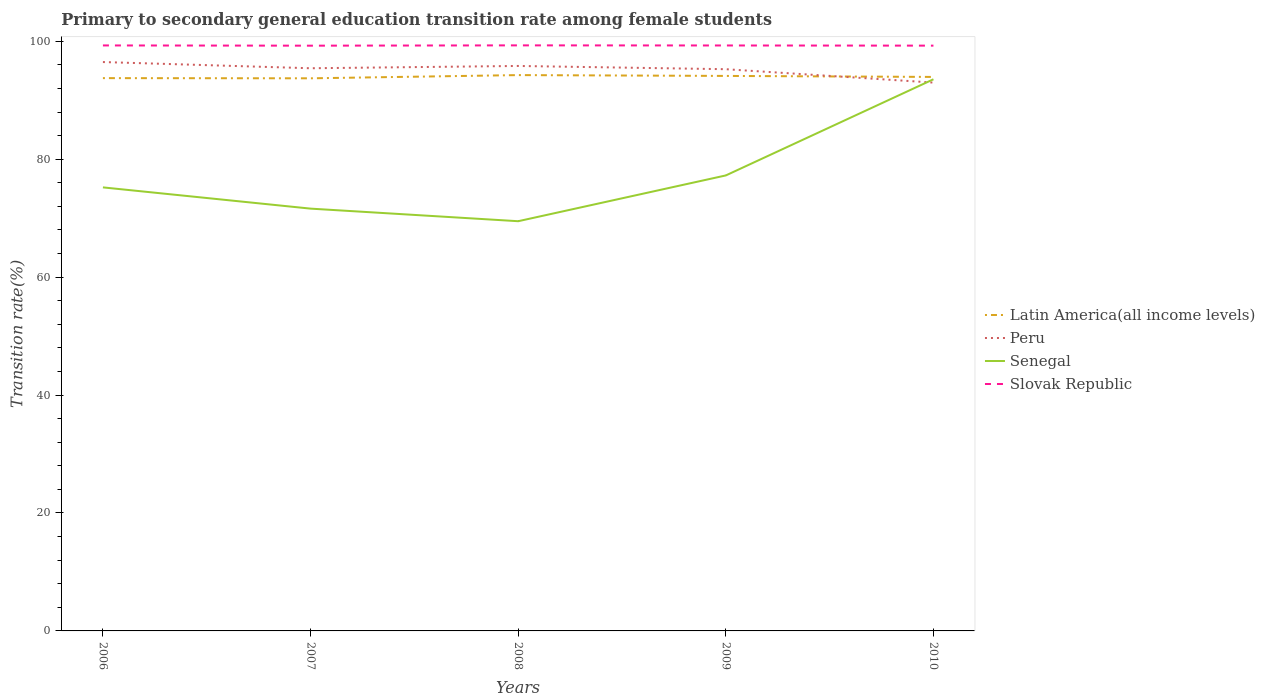Across all years, what is the maximum transition rate in Slovak Republic?
Provide a succinct answer. 99.25. In which year was the transition rate in Peru maximum?
Offer a very short reply. 2010. What is the total transition rate in Slovak Republic in the graph?
Keep it short and to the point. 0.02. What is the difference between the highest and the second highest transition rate in Latin America(all income levels)?
Ensure brevity in your answer.  0.54. What is the difference between the highest and the lowest transition rate in Senegal?
Your answer should be very brief. 1. How many lines are there?
Offer a very short reply. 4. How many years are there in the graph?
Your response must be concise. 5. What is the difference between two consecutive major ticks on the Y-axis?
Make the answer very short. 20. Does the graph contain any zero values?
Provide a succinct answer. No. Does the graph contain grids?
Ensure brevity in your answer.  No. Where does the legend appear in the graph?
Make the answer very short. Center right. How many legend labels are there?
Ensure brevity in your answer.  4. How are the legend labels stacked?
Your answer should be very brief. Vertical. What is the title of the graph?
Make the answer very short. Primary to secondary general education transition rate among female students. Does "Cabo Verde" appear as one of the legend labels in the graph?
Give a very brief answer. No. What is the label or title of the X-axis?
Provide a succinct answer. Years. What is the label or title of the Y-axis?
Offer a terse response. Transition rate(%). What is the Transition rate(%) in Latin America(all income levels) in 2006?
Provide a succinct answer. 93.74. What is the Transition rate(%) in Peru in 2006?
Ensure brevity in your answer.  96.47. What is the Transition rate(%) of Senegal in 2006?
Keep it short and to the point. 75.22. What is the Transition rate(%) in Slovak Republic in 2006?
Offer a terse response. 99.29. What is the Transition rate(%) in Latin America(all income levels) in 2007?
Provide a short and direct response. 93.71. What is the Transition rate(%) in Peru in 2007?
Give a very brief answer. 95.42. What is the Transition rate(%) in Senegal in 2007?
Make the answer very short. 71.61. What is the Transition rate(%) of Slovak Republic in 2007?
Your answer should be compact. 99.25. What is the Transition rate(%) of Latin America(all income levels) in 2008?
Your response must be concise. 94.26. What is the Transition rate(%) of Peru in 2008?
Keep it short and to the point. 95.81. What is the Transition rate(%) in Senegal in 2008?
Give a very brief answer. 69.48. What is the Transition rate(%) in Slovak Republic in 2008?
Make the answer very short. 99.3. What is the Transition rate(%) of Latin America(all income levels) in 2009?
Keep it short and to the point. 94.12. What is the Transition rate(%) of Peru in 2009?
Give a very brief answer. 95.26. What is the Transition rate(%) in Senegal in 2009?
Provide a short and direct response. 77.24. What is the Transition rate(%) of Slovak Republic in 2009?
Make the answer very short. 99.28. What is the Transition rate(%) in Latin America(all income levels) in 2010?
Make the answer very short. 93.95. What is the Transition rate(%) of Peru in 2010?
Offer a terse response. 92.99. What is the Transition rate(%) in Senegal in 2010?
Your answer should be compact. 93.55. What is the Transition rate(%) in Slovak Republic in 2010?
Offer a terse response. 99.25. Across all years, what is the maximum Transition rate(%) in Latin America(all income levels)?
Ensure brevity in your answer.  94.26. Across all years, what is the maximum Transition rate(%) in Peru?
Offer a very short reply. 96.47. Across all years, what is the maximum Transition rate(%) in Senegal?
Your response must be concise. 93.55. Across all years, what is the maximum Transition rate(%) in Slovak Republic?
Offer a very short reply. 99.3. Across all years, what is the minimum Transition rate(%) of Latin America(all income levels)?
Your response must be concise. 93.71. Across all years, what is the minimum Transition rate(%) of Peru?
Make the answer very short. 92.99. Across all years, what is the minimum Transition rate(%) of Senegal?
Give a very brief answer. 69.48. Across all years, what is the minimum Transition rate(%) in Slovak Republic?
Give a very brief answer. 99.25. What is the total Transition rate(%) of Latin America(all income levels) in the graph?
Your response must be concise. 469.78. What is the total Transition rate(%) of Peru in the graph?
Give a very brief answer. 475.95. What is the total Transition rate(%) of Senegal in the graph?
Make the answer very short. 387.1. What is the total Transition rate(%) in Slovak Republic in the graph?
Give a very brief answer. 496.37. What is the difference between the Transition rate(%) in Latin America(all income levels) in 2006 and that in 2007?
Make the answer very short. 0.03. What is the difference between the Transition rate(%) of Peru in 2006 and that in 2007?
Offer a terse response. 1.05. What is the difference between the Transition rate(%) of Senegal in 2006 and that in 2007?
Give a very brief answer. 3.6. What is the difference between the Transition rate(%) of Slovak Republic in 2006 and that in 2007?
Provide a succinct answer. 0.04. What is the difference between the Transition rate(%) in Latin America(all income levels) in 2006 and that in 2008?
Offer a very short reply. -0.51. What is the difference between the Transition rate(%) in Peru in 2006 and that in 2008?
Offer a very short reply. 0.66. What is the difference between the Transition rate(%) of Senegal in 2006 and that in 2008?
Offer a terse response. 5.74. What is the difference between the Transition rate(%) of Slovak Republic in 2006 and that in 2008?
Give a very brief answer. -0.01. What is the difference between the Transition rate(%) in Latin America(all income levels) in 2006 and that in 2009?
Offer a terse response. -0.37. What is the difference between the Transition rate(%) in Peru in 2006 and that in 2009?
Provide a succinct answer. 1.21. What is the difference between the Transition rate(%) of Senegal in 2006 and that in 2009?
Offer a very short reply. -2.03. What is the difference between the Transition rate(%) in Slovak Republic in 2006 and that in 2009?
Ensure brevity in your answer.  0.01. What is the difference between the Transition rate(%) in Latin America(all income levels) in 2006 and that in 2010?
Give a very brief answer. -0.2. What is the difference between the Transition rate(%) of Peru in 2006 and that in 2010?
Provide a succinct answer. 3.48. What is the difference between the Transition rate(%) of Senegal in 2006 and that in 2010?
Offer a very short reply. -18.33. What is the difference between the Transition rate(%) in Slovak Republic in 2006 and that in 2010?
Provide a short and direct response. 0.03. What is the difference between the Transition rate(%) of Latin America(all income levels) in 2007 and that in 2008?
Your answer should be compact. -0.54. What is the difference between the Transition rate(%) of Peru in 2007 and that in 2008?
Make the answer very short. -0.39. What is the difference between the Transition rate(%) of Senegal in 2007 and that in 2008?
Provide a short and direct response. 2.13. What is the difference between the Transition rate(%) in Slovak Republic in 2007 and that in 2008?
Ensure brevity in your answer.  -0.05. What is the difference between the Transition rate(%) of Latin America(all income levels) in 2007 and that in 2009?
Your answer should be very brief. -0.41. What is the difference between the Transition rate(%) of Peru in 2007 and that in 2009?
Offer a very short reply. 0.16. What is the difference between the Transition rate(%) of Senegal in 2007 and that in 2009?
Give a very brief answer. -5.63. What is the difference between the Transition rate(%) of Slovak Republic in 2007 and that in 2009?
Offer a terse response. -0.03. What is the difference between the Transition rate(%) of Latin America(all income levels) in 2007 and that in 2010?
Give a very brief answer. -0.23. What is the difference between the Transition rate(%) in Peru in 2007 and that in 2010?
Your response must be concise. 2.43. What is the difference between the Transition rate(%) in Senegal in 2007 and that in 2010?
Offer a terse response. -21.94. What is the difference between the Transition rate(%) in Slovak Republic in 2007 and that in 2010?
Offer a terse response. -0.01. What is the difference between the Transition rate(%) of Latin America(all income levels) in 2008 and that in 2009?
Your answer should be compact. 0.14. What is the difference between the Transition rate(%) in Peru in 2008 and that in 2009?
Provide a short and direct response. 0.55. What is the difference between the Transition rate(%) in Senegal in 2008 and that in 2009?
Provide a short and direct response. -7.76. What is the difference between the Transition rate(%) in Slovak Republic in 2008 and that in 2009?
Your answer should be very brief. 0.02. What is the difference between the Transition rate(%) of Latin America(all income levels) in 2008 and that in 2010?
Your answer should be compact. 0.31. What is the difference between the Transition rate(%) in Peru in 2008 and that in 2010?
Your answer should be compact. 2.82. What is the difference between the Transition rate(%) of Senegal in 2008 and that in 2010?
Give a very brief answer. -24.07. What is the difference between the Transition rate(%) of Slovak Republic in 2008 and that in 2010?
Make the answer very short. 0.05. What is the difference between the Transition rate(%) of Latin America(all income levels) in 2009 and that in 2010?
Provide a succinct answer. 0.17. What is the difference between the Transition rate(%) of Peru in 2009 and that in 2010?
Your response must be concise. 2.27. What is the difference between the Transition rate(%) in Senegal in 2009 and that in 2010?
Provide a succinct answer. -16.31. What is the difference between the Transition rate(%) of Slovak Republic in 2009 and that in 2010?
Keep it short and to the point. 0.03. What is the difference between the Transition rate(%) in Latin America(all income levels) in 2006 and the Transition rate(%) in Peru in 2007?
Offer a terse response. -1.67. What is the difference between the Transition rate(%) in Latin America(all income levels) in 2006 and the Transition rate(%) in Senegal in 2007?
Provide a succinct answer. 22.13. What is the difference between the Transition rate(%) in Latin America(all income levels) in 2006 and the Transition rate(%) in Slovak Republic in 2007?
Ensure brevity in your answer.  -5.5. What is the difference between the Transition rate(%) in Peru in 2006 and the Transition rate(%) in Senegal in 2007?
Provide a succinct answer. 24.86. What is the difference between the Transition rate(%) in Peru in 2006 and the Transition rate(%) in Slovak Republic in 2007?
Make the answer very short. -2.78. What is the difference between the Transition rate(%) of Senegal in 2006 and the Transition rate(%) of Slovak Republic in 2007?
Your answer should be very brief. -24.03. What is the difference between the Transition rate(%) of Latin America(all income levels) in 2006 and the Transition rate(%) of Peru in 2008?
Provide a short and direct response. -2.06. What is the difference between the Transition rate(%) of Latin America(all income levels) in 2006 and the Transition rate(%) of Senegal in 2008?
Offer a terse response. 24.26. What is the difference between the Transition rate(%) in Latin America(all income levels) in 2006 and the Transition rate(%) in Slovak Republic in 2008?
Provide a succinct answer. -5.56. What is the difference between the Transition rate(%) of Peru in 2006 and the Transition rate(%) of Senegal in 2008?
Offer a very short reply. 26.99. What is the difference between the Transition rate(%) of Peru in 2006 and the Transition rate(%) of Slovak Republic in 2008?
Your answer should be compact. -2.83. What is the difference between the Transition rate(%) in Senegal in 2006 and the Transition rate(%) in Slovak Republic in 2008?
Keep it short and to the point. -24.08. What is the difference between the Transition rate(%) of Latin America(all income levels) in 2006 and the Transition rate(%) of Peru in 2009?
Your answer should be compact. -1.51. What is the difference between the Transition rate(%) of Latin America(all income levels) in 2006 and the Transition rate(%) of Senegal in 2009?
Provide a short and direct response. 16.5. What is the difference between the Transition rate(%) of Latin America(all income levels) in 2006 and the Transition rate(%) of Slovak Republic in 2009?
Your answer should be compact. -5.54. What is the difference between the Transition rate(%) in Peru in 2006 and the Transition rate(%) in Senegal in 2009?
Your answer should be very brief. 19.23. What is the difference between the Transition rate(%) of Peru in 2006 and the Transition rate(%) of Slovak Republic in 2009?
Provide a short and direct response. -2.81. What is the difference between the Transition rate(%) in Senegal in 2006 and the Transition rate(%) in Slovak Republic in 2009?
Give a very brief answer. -24.06. What is the difference between the Transition rate(%) of Latin America(all income levels) in 2006 and the Transition rate(%) of Peru in 2010?
Offer a terse response. 0.76. What is the difference between the Transition rate(%) in Latin America(all income levels) in 2006 and the Transition rate(%) in Senegal in 2010?
Make the answer very short. 0.2. What is the difference between the Transition rate(%) in Latin America(all income levels) in 2006 and the Transition rate(%) in Slovak Republic in 2010?
Offer a very short reply. -5.51. What is the difference between the Transition rate(%) in Peru in 2006 and the Transition rate(%) in Senegal in 2010?
Provide a short and direct response. 2.92. What is the difference between the Transition rate(%) of Peru in 2006 and the Transition rate(%) of Slovak Republic in 2010?
Ensure brevity in your answer.  -2.78. What is the difference between the Transition rate(%) of Senegal in 2006 and the Transition rate(%) of Slovak Republic in 2010?
Keep it short and to the point. -24.04. What is the difference between the Transition rate(%) of Latin America(all income levels) in 2007 and the Transition rate(%) of Peru in 2008?
Offer a terse response. -2.09. What is the difference between the Transition rate(%) in Latin America(all income levels) in 2007 and the Transition rate(%) in Senegal in 2008?
Provide a short and direct response. 24.23. What is the difference between the Transition rate(%) of Latin America(all income levels) in 2007 and the Transition rate(%) of Slovak Republic in 2008?
Your answer should be compact. -5.59. What is the difference between the Transition rate(%) of Peru in 2007 and the Transition rate(%) of Senegal in 2008?
Give a very brief answer. 25.94. What is the difference between the Transition rate(%) of Peru in 2007 and the Transition rate(%) of Slovak Republic in 2008?
Make the answer very short. -3.88. What is the difference between the Transition rate(%) of Senegal in 2007 and the Transition rate(%) of Slovak Republic in 2008?
Offer a terse response. -27.69. What is the difference between the Transition rate(%) in Latin America(all income levels) in 2007 and the Transition rate(%) in Peru in 2009?
Your response must be concise. -1.55. What is the difference between the Transition rate(%) of Latin America(all income levels) in 2007 and the Transition rate(%) of Senegal in 2009?
Provide a succinct answer. 16.47. What is the difference between the Transition rate(%) of Latin America(all income levels) in 2007 and the Transition rate(%) of Slovak Republic in 2009?
Keep it short and to the point. -5.57. What is the difference between the Transition rate(%) in Peru in 2007 and the Transition rate(%) in Senegal in 2009?
Provide a succinct answer. 18.18. What is the difference between the Transition rate(%) in Peru in 2007 and the Transition rate(%) in Slovak Republic in 2009?
Give a very brief answer. -3.86. What is the difference between the Transition rate(%) in Senegal in 2007 and the Transition rate(%) in Slovak Republic in 2009?
Your answer should be very brief. -27.67. What is the difference between the Transition rate(%) of Latin America(all income levels) in 2007 and the Transition rate(%) of Peru in 2010?
Your answer should be very brief. 0.73. What is the difference between the Transition rate(%) of Latin America(all income levels) in 2007 and the Transition rate(%) of Senegal in 2010?
Your response must be concise. 0.16. What is the difference between the Transition rate(%) in Latin America(all income levels) in 2007 and the Transition rate(%) in Slovak Republic in 2010?
Your answer should be very brief. -5.54. What is the difference between the Transition rate(%) of Peru in 2007 and the Transition rate(%) of Senegal in 2010?
Offer a terse response. 1.87. What is the difference between the Transition rate(%) of Peru in 2007 and the Transition rate(%) of Slovak Republic in 2010?
Provide a succinct answer. -3.83. What is the difference between the Transition rate(%) in Senegal in 2007 and the Transition rate(%) in Slovak Republic in 2010?
Make the answer very short. -27.64. What is the difference between the Transition rate(%) in Latin America(all income levels) in 2008 and the Transition rate(%) in Peru in 2009?
Your answer should be very brief. -1. What is the difference between the Transition rate(%) in Latin America(all income levels) in 2008 and the Transition rate(%) in Senegal in 2009?
Offer a very short reply. 17.01. What is the difference between the Transition rate(%) in Latin America(all income levels) in 2008 and the Transition rate(%) in Slovak Republic in 2009?
Offer a very short reply. -5.02. What is the difference between the Transition rate(%) in Peru in 2008 and the Transition rate(%) in Senegal in 2009?
Offer a very short reply. 18.56. What is the difference between the Transition rate(%) of Peru in 2008 and the Transition rate(%) of Slovak Republic in 2009?
Ensure brevity in your answer.  -3.47. What is the difference between the Transition rate(%) of Senegal in 2008 and the Transition rate(%) of Slovak Republic in 2009?
Make the answer very short. -29.8. What is the difference between the Transition rate(%) in Latin America(all income levels) in 2008 and the Transition rate(%) in Peru in 2010?
Make the answer very short. 1.27. What is the difference between the Transition rate(%) of Latin America(all income levels) in 2008 and the Transition rate(%) of Senegal in 2010?
Ensure brevity in your answer.  0.71. What is the difference between the Transition rate(%) of Latin America(all income levels) in 2008 and the Transition rate(%) of Slovak Republic in 2010?
Provide a succinct answer. -5. What is the difference between the Transition rate(%) in Peru in 2008 and the Transition rate(%) in Senegal in 2010?
Your answer should be very brief. 2.26. What is the difference between the Transition rate(%) of Peru in 2008 and the Transition rate(%) of Slovak Republic in 2010?
Offer a very short reply. -3.45. What is the difference between the Transition rate(%) of Senegal in 2008 and the Transition rate(%) of Slovak Republic in 2010?
Give a very brief answer. -29.77. What is the difference between the Transition rate(%) in Latin America(all income levels) in 2009 and the Transition rate(%) in Peru in 2010?
Offer a terse response. 1.13. What is the difference between the Transition rate(%) of Latin America(all income levels) in 2009 and the Transition rate(%) of Senegal in 2010?
Keep it short and to the point. 0.57. What is the difference between the Transition rate(%) in Latin America(all income levels) in 2009 and the Transition rate(%) in Slovak Republic in 2010?
Provide a short and direct response. -5.14. What is the difference between the Transition rate(%) of Peru in 2009 and the Transition rate(%) of Senegal in 2010?
Make the answer very short. 1.71. What is the difference between the Transition rate(%) in Peru in 2009 and the Transition rate(%) in Slovak Republic in 2010?
Provide a short and direct response. -4. What is the difference between the Transition rate(%) of Senegal in 2009 and the Transition rate(%) of Slovak Republic in 2010?
Give a very brief answer. -22.01. What is the average Transition rate(%) of Latin America(all income levels) per year?
Offer a terse response. 93.96. What is the average Transition rate(%) of Peru per year?
Ensure brevity in your answer.  95.19. What is the average Transition rate(%) of Senegal per year?
Your response must be concise. 77.42. What is the average Transition rate(%) in Slovak Republic per year?
Your answer should be compact. 99.27. In the year 2006, what is the difference between the Transition rate(%) in Latin America(all income levels) and Transition rate(%) in Peru?
Keep it short and to the point. -2.73. In the year 2006, what is the difference between the Transition rate(%) of Latin America(all income levels) and Transition rate(%) of Senegal?
Ensure brevity in your answer.  18.53. In the year 2006, what is the difference between the Transition rate(%) of Latin America(all income levels) and Transition rate(%) of Slovak Republic?
Ensure brevity in your answer.  -5.54. In the year 2006, what is the difference between the Transition rate(%) of Peru and Transition rate(%) of Senegal?
Provide a short and direct response. 21.26. In the year 2006, what is the difference between the Transition rate(%) of Peru and Transition rate(%) of Slovak Republic?
Offer a terse response. -2.82. In the year 2006, what is the difference between the Transition rate(%) in Senegal and Transition rate(%) in Slovak Republic?
Give a very brief answer. -24.07. In the year 2007, what is the difference between the Transition rate(%) in Latin America(all income levels) and Transition rate(%) in Peru?
Offer a very short reply. -1.71. In the year 2007, what is the difference between the Transition rate(%) in Latin America(all income levels) and Transition rate(%) in Senegal?
Provide a succinct answer. 22.1. In the year 2007, what is the difference between the Transition rate(%) of Latin America(all income levels) and Transition rate(%) of Slovak Republic?
Your answer should be compact. -5.54. In the year 2007, what is the difference between the Transition rate(%) in Peru and Transition rate(%) in Senegal?
Provide a succinct answer. 23.81. In the year 2007, what is the difference between the Transition rate(%) of Peru and Transition rate(%) of Slovak Republic?
Provide a succinct answer. -3.83. In the year 2007, what is the difference between the Transition rate(%) in Senegal and Transition rate(%) in Slovak Republic?
Provide a short and direct response. -27.63. In the year 2008, what is the difference between the Transition rate(%) of Latin America(all income levels) and Transition rate(%) of Peru?
Give a very brief answer. -1.55. In the year 2008, what is the difference between the Transition rate(%) of Latin America(all income levels) and Transition rate(%) of Senegal?
Make the answer very short. 24.78. In the year 2008, what is the difference between the Transition rate(%) in Latin America(all income levels) and Transition rate(%) in Slovak Republic?
Your answer should be compact. -5.04. In the year 2008, what is the difference between the Transition rate(%) in Peru and Transition rate(%) in Senegal?
Provide a succinct answer. 26.33. In the year 2008, what is the difference between the Transition rate(%) in Peru and Transition rate(%) in Slovak Republic?
Your response must be concise. -3.49. In the year 2008, what is the difference between the Transition rate(%) in Senegal and Transition rate(%) in Slovak Republic?
Offer a very short reply. -29.82. In the year 2009, what is the difference between the Transition rate(%) in Latin America(all income levels) and Transition rate(%) in Peru?
Your answer should be compact. -1.14. In the year 2009, what is the difference between the Transition rate(%) of Latin America(all income levels) and Transition rate(%) of Senegal?
Provide a succinct answer. 16.88. In the year 2009, what is the difference between the Transition rate(%) of Latin America(all income levels) and Transition rate(%) of Slovak Republic?
Your answer should be compact. -5.16. In the year 2009, what is the difference between the Transition rate(%) of Peru and Transition rate(%) of Senegal?
Your answer should be very brief. 18.02. In the year 2009, what is the difference between the Transition rate(%) in Peru and Transition rate(%) in Slovak Republic?
Provide a succinct answer. -4.02. In the year 2009, what is the difference between the Transition rate(%) of Senegal and Transition rate(%) of Slovak Republic?
Give a very brief answer. -22.04. In the year 2010, what is the difference between the Transition rate(%) of Latin America(all income levels) and Transition rate(%) of Senegal?
Your response must be concise. 0.4. In the year 2010, what is the difference between the Transition rate(%) of Latin America(all income levels) and Transition rate(%) of Slovak Republic?
Make the answer very short. -5.31. In the year 2010, what is the difference between the Transition rate(%) of Peru and Transition rate(%) of Senegal?
Your answer should be very brief. -0.56. In the year 2010, what is the difference between the Transition rate(%) in Peru and Transition rate(%) in Slovak Republic?
Offer a very short reply. -6.27. In the year 2010, what is the difference between the Transition rate(%) in Senegal and Transition rate(%) in Slovak Republic?
Give a very brief answer. -5.7. What is the ratio of the Transition rate(%) in Latin America(all income levels) in 2006 to that in 2007?
Offer a terse response. 1. What is the ratio of the Transition rate(%) in Peru in 2006 to that in 2007?
Offer a terse response. 1.01. What is the ratio of the Transition rate(%) in Senegal in 2006 to that in 2007?
Keep it short and to the point. 1.05. What is the ratio of the Transition rate(%) in Slovak Republic in 2006 to that in 2007?
Make the answer very short. 1. What is the ratio of the Transition rate(%) of Latin America(all income levels) in 2006 to that in 2008?
Make the answer very short. 0.99. What is the ratio of the Transition rate(%) in Senegal in 2006 to that in 2008?
Keep it short and to the point. 1.08. What is the ratio of the Transition rate(%) of Slovak Republic in 2006 to that in 2008?
Offer a terse response. 1. What is the ratio of the Transition rate(%) in Latin America(all income levels) in 2006 to that in 2009?
Keep it short and to the point. 1. What is the ratio of the Transition rate(%) in Peru in 2006 to that in 2009?
Your answer should be compact. 1.01. What is the ratio of the Transition rate(%) of Senegal in 2006 to that in 2009?
Offer a very short reply. 0.97. What is the ratio of the Transition rate(%) in Latin America(all income levels) in 2006 to that in 2010?
Provide a succinct answer. 1. What is the ratio of the Transition rate(%) of Peru in 2006 to that in 2010?
Offer a terse response. 1.04. What is the ratio of the Transition rate(%) of Senegal in 2006 to that in 2010?
Keep it short and to the point. 0.8. What is the ratio of the Transition rate(%) in Slovak Republic in 2006 to that in 2010?
Provide a succinct answer. 1. What is the ratio of the Transition rate(%) of Latin America(all income levels) in 2007 to that in 2008?
Your response must be concise. 0.99. What is the ratio of the Transition rate(%) in Peru in 2007 to that in 2008?
Your answer should be very brief. 1. What is the ratio of the Transition rate(%) in Senegal in 2007 to that in 2008?
Your answer should be compact. 1.03. What is the ratio of the Transition rate(%) in Slovak Republic in 2007 to that in 2008?
Your answer should be compact. 1. What is the ratio of the Transition rate(%) in Latin America(all income levels) in 2007 to that in 2009?
Keep it short and to the point. 1. What is the ratio of the Transition rate(%) of Peru in 2007 to that in 2009?
Provide a succinct answer. 1. What is the ratio of the Transition rate(%) in Senegal in 2007 to that in 2009?
Offer a terse response. 0.93. What is the ratio of the Transition rate(%) in Peru in 2007 to that in 2010?
Your answer should be compact. 1.03. What is the ratio of the Transition rate(%) of Senegal in 2007 to that in 2010?
Your answer should be compact. 0.77. What is the ratio of the Transition rate(%) in Slovak Republic in 2007 to that in 2010?
Keep it short and to the point. 1. What is the ratio of the Transition rate(%) of Latin America(all income levels) in 2008 to that in 2009?
Your answer should be very brief. 1. What is the ratio of the Transition rate(%) in Peru in 2008 to that in 2009?
Keep it short and to the point. 1.01. What is the ratio of the Transition rate(%) of Senegal in 2008 to that in 2009?
Your response must be concise. 0.9. What is the ratio of the Transition rate(%) in Slovak Republic in 2008 to that in 2009?
Your answer should be compact. 1. What is the ratio of the Transition rate(%) in Peru in 2008 to that in 2010?
Your response must be concise. 1.03. What is the ratio of the Transition rate(%) of Senegal in 2008 to that in 2010?
Your answer should be compact. 0.74. What is the ratio of the Transition rate(%) of Peru in 2009 to that in 2010?
Give a very brief answer. 1.02. What is the ratio of the Transition rate(%) of Senegal in 2009 to that in 2010?
Keep it short and to the point. 0.83. What is the difference between the highest and the second highest Transition rate(%) of Latin America(all income levels)?
Provide a succinct answer. 0.14. What is the difference between the highest and the second highest Transition rate(%) of Peru?
Provide a succinct answer. 0.66. What is the difference between the highest and the second highest Transition rate(%) of Senegal?
Offer a very short reply. 16.31. What is the difference between the highest and the second highest Transition rate(%) of Slovak Republic?
Your answer should be very brief. 0.01. What is the difference between the highest and the lowest Transition rate(%) in Latin America(all income levels)?
Offer a very short reply. 0.54. What is the difference between the highest and the lowest Transition rate(%) in Peru?
Your response must be concise. 3.48. What is the difference between the highest and the lowest Transition rate(%) of Senegal?
Keep it short and to the point. 24.07. What is the difference between the highest and the lowest Transition rate(%) of Slovak Republic?
Your answer should be compact. 0.05. 